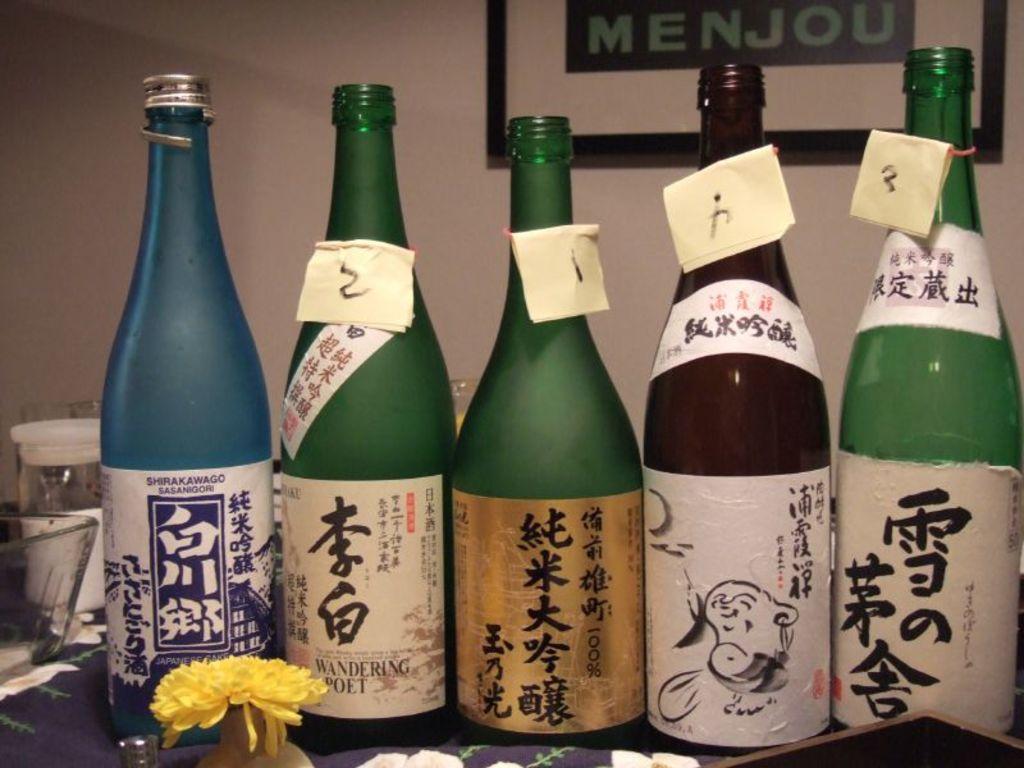In one or two sentences, can you explain what this image depicts? In this picture, there are bottles with different colors and labels. On every level, there is some text. At the bottom, there is a flower. Towards the left, there is a bowl and a jar. In the background, there is a wall with a frame. 